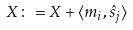<formula> <loc_0><loc_0><loc_500><loc_500>X \colon = X + \langle m _ { i } , \hat { s } _ { j } \rangle</formula> 